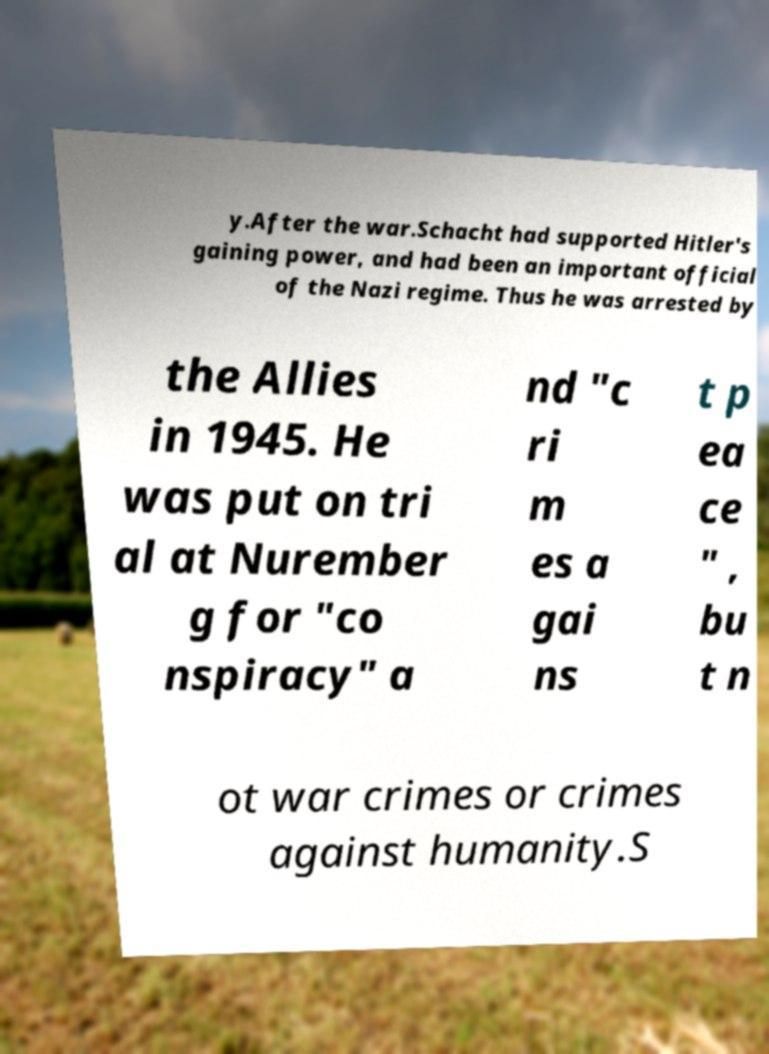What messages or text are displayed in this image? I need them in a readable, typed format. y.After the war.Schacht had supported Hitler's gaining power, and had been an important official of the Nazi regime. Thus he was arrested by the Allies in 1945. He was put on tri al at Nurember g for "co nspiracy" a nd "c ri m es a gai ns t p ea ce " , bu t n ot war crimes or crimes against humanity.S 